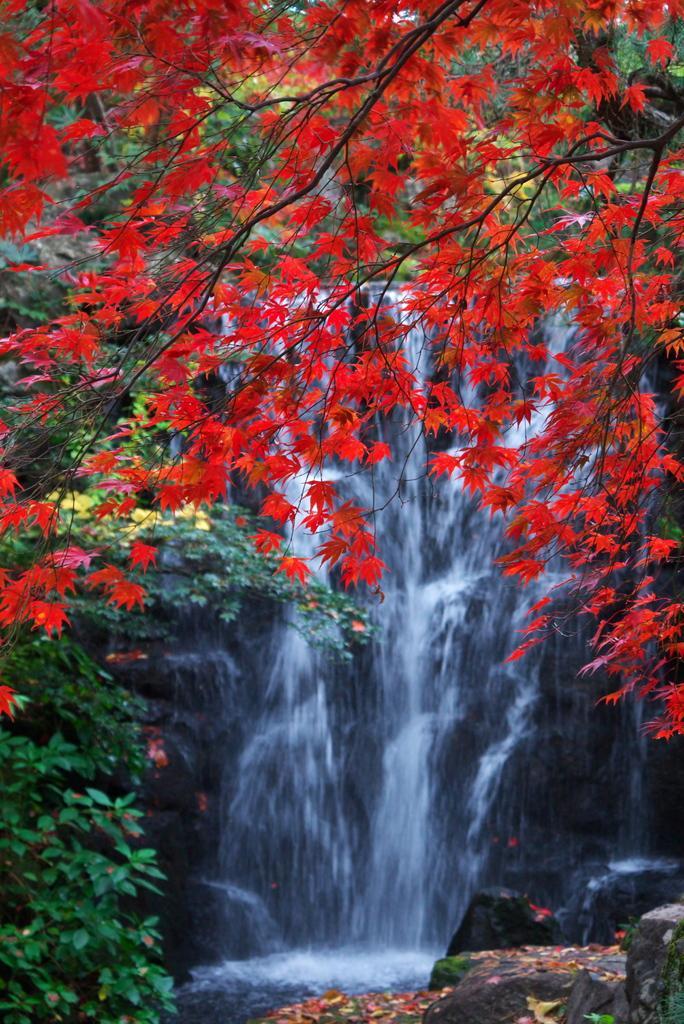Could you give a brief overview of what you see in this image? In this picture we can see water, few trees and few rocks. 